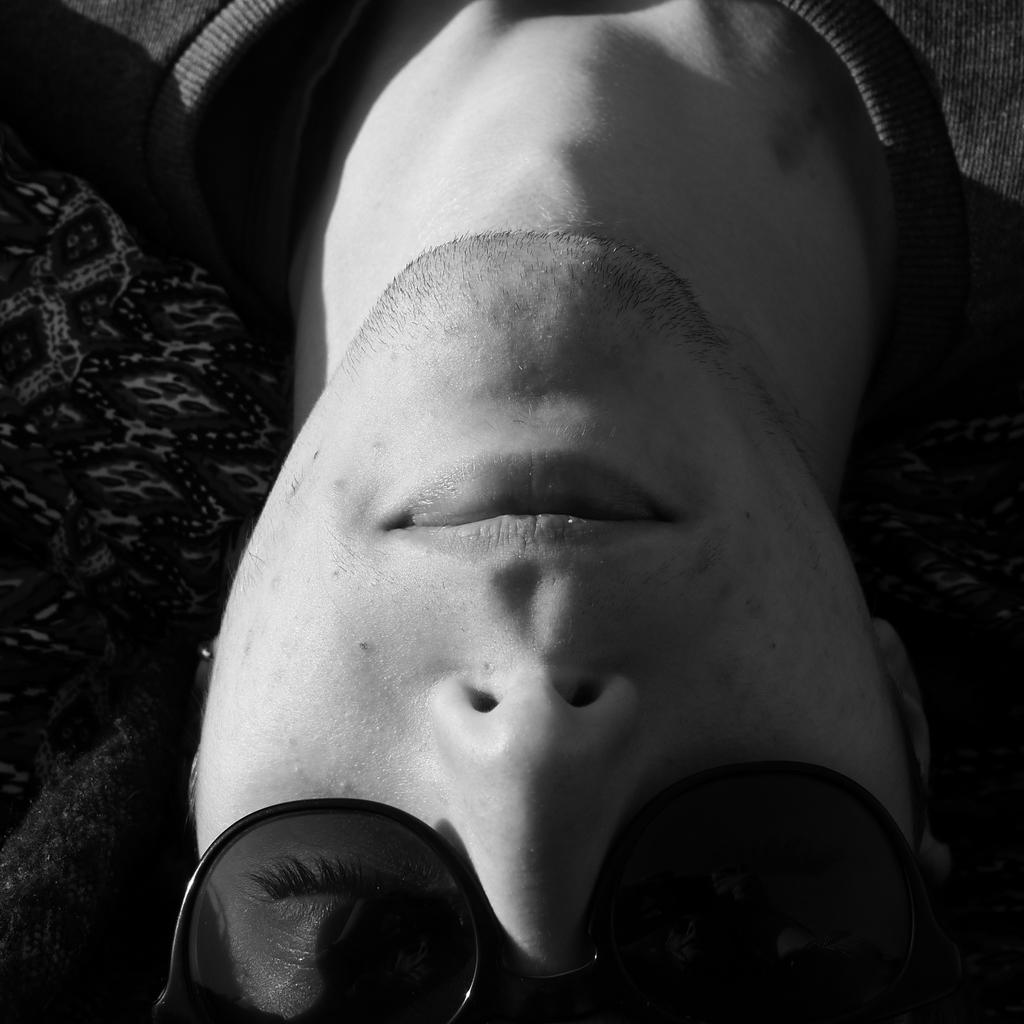What is present in the image? There is a person in the image. What part of the person's body can be seen? The person's head and neck are visible. What accessory is the person wearing? The person is wearing spectacles. What type of juice is the person holding in the image? There is no juice present in the image; the person is wearing spectacles. 